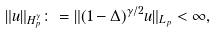Convert formula to latex. <formula><loc_0><loc_0><loc_500><loc_500>\| u \| _ { H _ { p } ^ { \gamma } } \colon = \| ( 1 - \Delta ) ^ { \gamma / 2 } u \| _ { L _ { p } } < \infty ,</formula> 